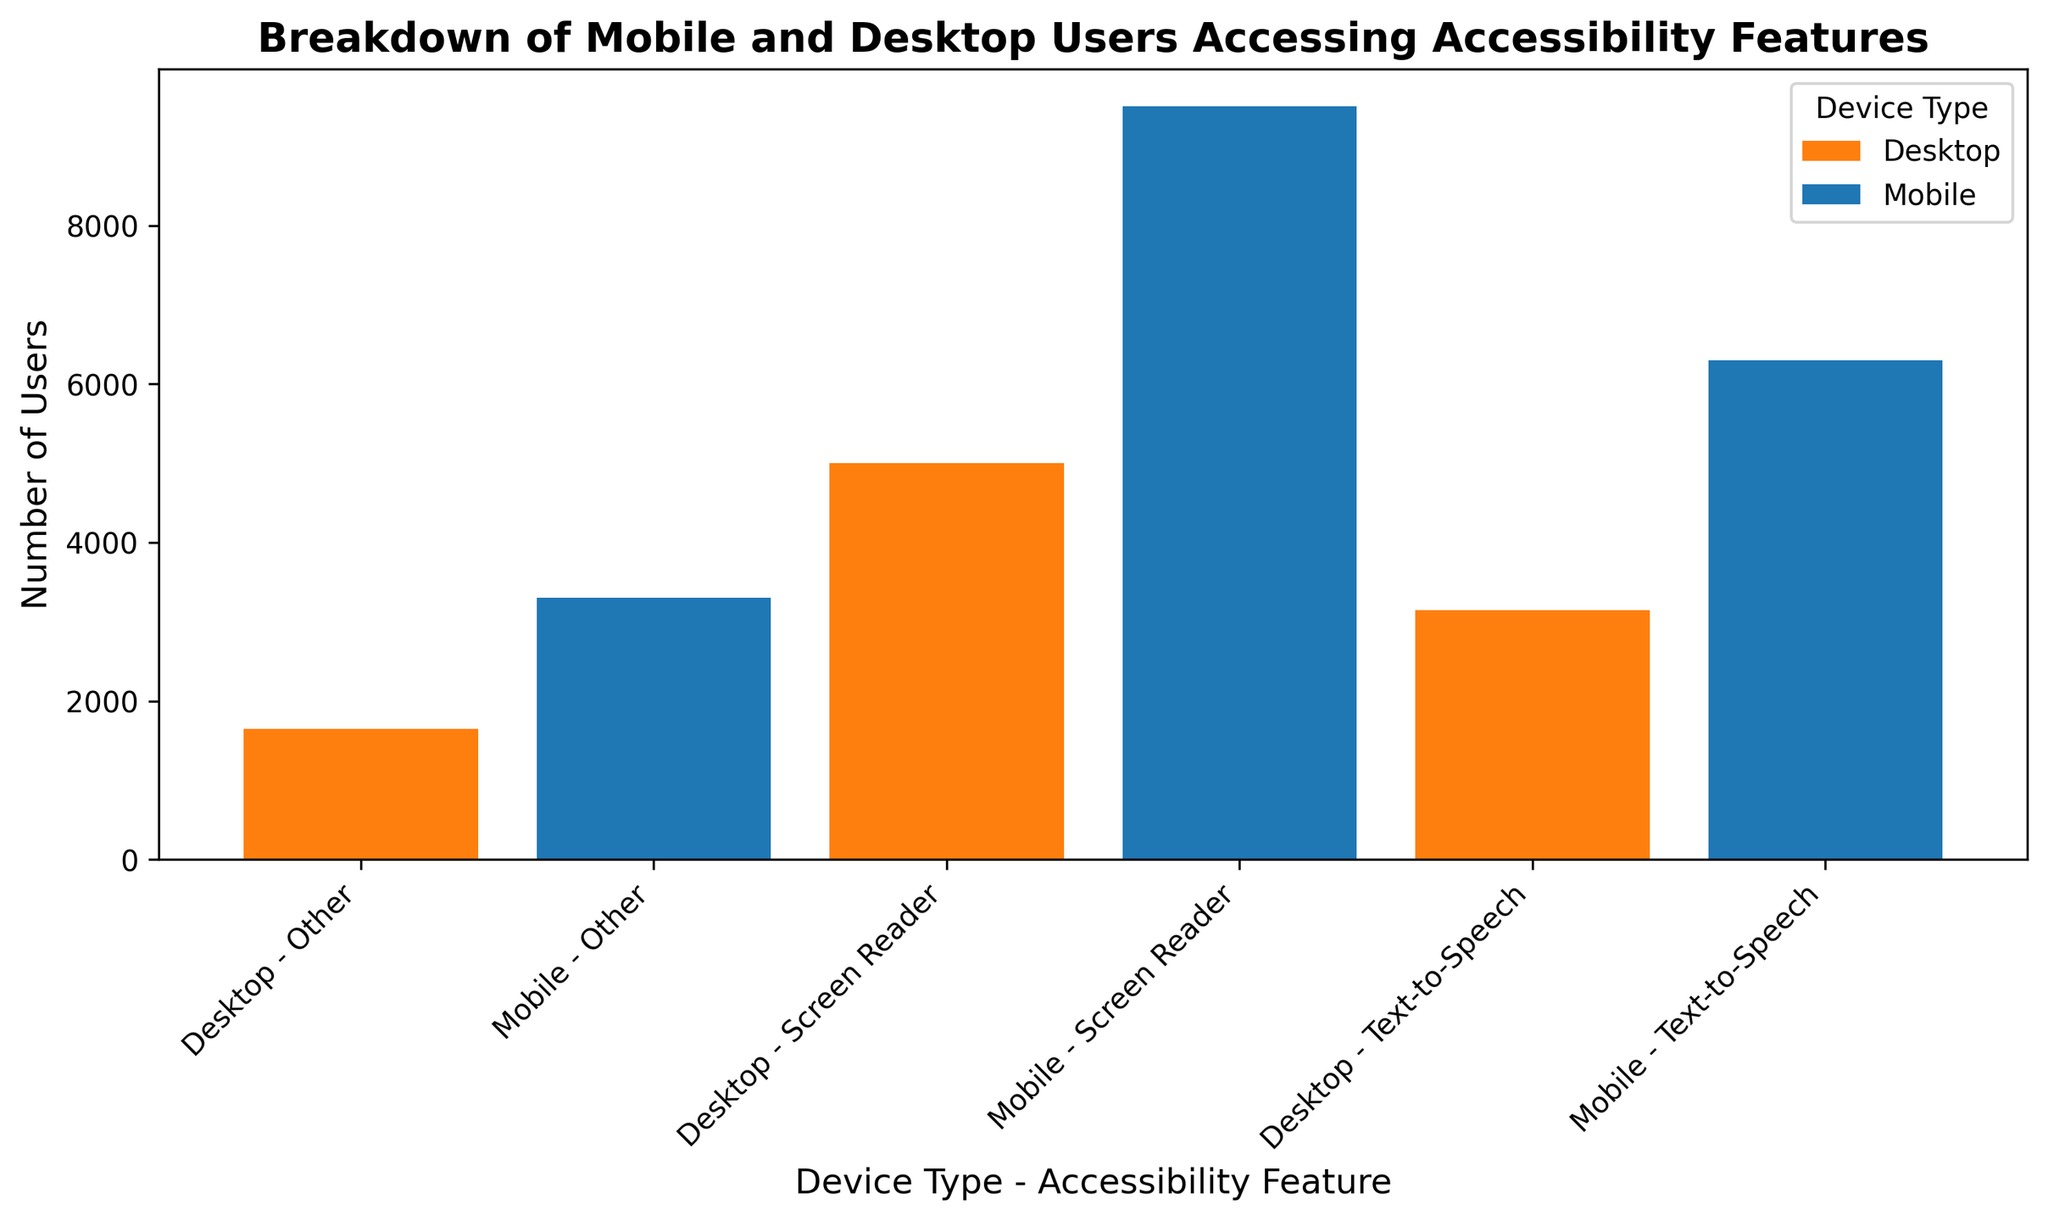What is the total number of mobile users utilizing screen readers? First, identify the bars representing mobile users using screen readers. Next, sum the height of these bars. The heights are 3000, 3200, and 3300. Thus, 3000 + 3200 + 3300 = 9500.
Answer: 9500 Which device type has the highest number of users for text-to-speech accessibility features? Check the heights of the bars for text-to-speech users on both mobile and desktop devices. The height for mobile text-to-speech users is 2000 + 2100 + 2200 = 6300 and for desktop is 1000 + 1050 + 1100 = 3150. Thus, mobile has the highest count.
Answer: Mobile Compare the number of desktop users using screen readers to those using other accessibility features. Which is greater? Sum the users of desktop screen readers (1500 + 1700 + 1800 = 5000) and other features (500 + 550 + 600 = 1650). Therefore, 5000 (screen readers) is greater than 1650 (other features).
Answer: Screen readers Which category of accessibility features has the lowest number of users across mobile and desktop combined? To determine this, we sum the users for each feature across both mobile and desktop devices. For screen readers, it is 9500 (mobile) + 5000 (desktop) = 14500. For text-to-speech, it is 6300 (mobile) + 3150 (desktop) = 9450. For other features, it is 3300 (mobile) + 1650 (desktop) = 4950. Thus, the category with the lowest number is Other.
Answer: Other What is the average number of desktop users for screen readers? Sum the number of desktop screen reader users, 1500 + 1700 + 1800 = 5000. The number of data points is 3. Divide the total by the number of data points, 5000 / 3 ≈ 1666.67.
Answer: ~1667 